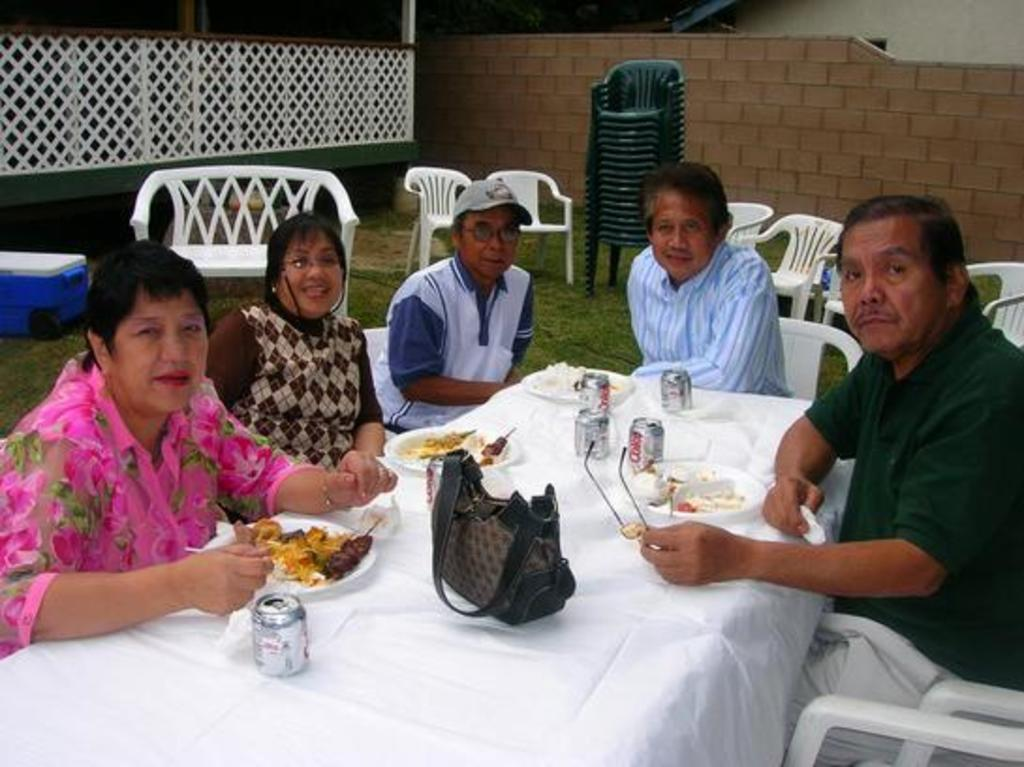What are the people in the image doing? The people in the image are sitting on chairs. What is present on the table in the image? There is a table in the image, and there are food items on a plate on the table. What else can be seen on the table? There are coke cans on the table in the image. What item is present that might be used to carry personal belongings? There is a purse in the image. Can you see any smoke coming from the dock in the image? There is no dock present in the image, and therefore no smoke can be seen. 